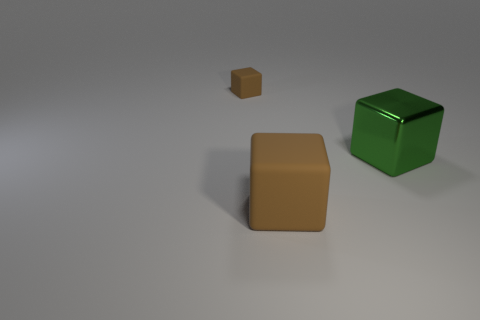Add 3 large green shiny things. How many objects exist? 6 Add 2 green shiny cubes. How many green shiny cubes are left? 3 Add 3 brown blocks. How many brown blocks exist? 5 Subtract 0 purple balls. How many objects are left? 3 Subtract all big rubber things. Subtract all large yellow rubber objects. How many objects are left? 2 